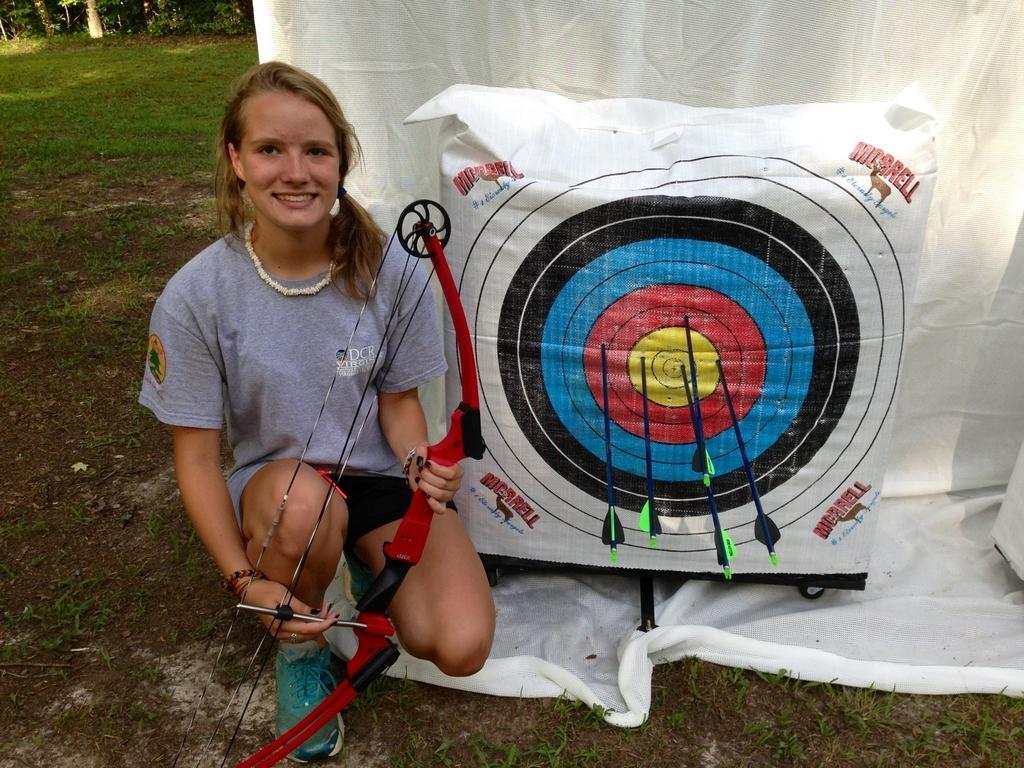Could you give a brief overview of what you see in this image? In this image a lady holding a arrow in her hands, beside the lady there is a target board, in the background there is a white cloth and trees. 